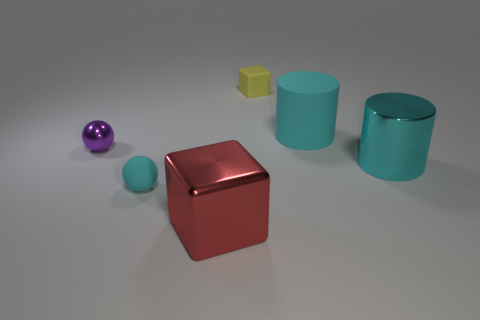The object that is both on the left side of the large block and in front of the tiny metal ball is made of what material?
Your answer should be compact. Rubber. What color is the other thing that is the same shape as the big red thing?
Your response must be concise. Yellow. The yellow thing has what size?
Give a very brief answer. Small. There is a object in front of the rubber thing in front of the purple object; what is its color?
Ensure brevity in your answer.  Red. How many cyan objects are both behind the tiny purple metal thing and in front of the cyan shiny object?
Keep it short and to the point. 0. Is the number of small matte balls greater than the number of blue metallic balls?
Provide a short and direct response. Yes. What is the tiny cyan object made of?
Offer a terse response. Rubber. What number of blocks are in front of the tiny thing right of the big red metallic block?
Provide a short and direct response. 1. Is the color of the big shiny cylinder the same as the small sphere that is behind the tiny cyan matte sphere?
Your answer should be very brief. No. There is a rubber cylinder that is the same size as the metallic block; what color is it?
Keep it short and to the point. Cyan. 